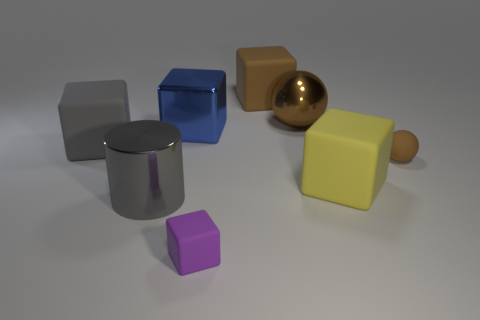Subtract all gray matte cubes. How many cubes are left? 4 Subtract all brown blocks. How many blocks are left? 4 Add 1 metal spheres. How many objects exist? 9 Subtract all blocks. How many objects are left? 3 Add 4 gray objects. How many gray objects are left? 6 Add 5 big blue metal cubes. How many big blue metal cubes exist? 6 Subtract 1 purple cubes. How many objects are left? 7 Subtract all cyan blocks. Subtract all green balls. How many blocks are left? 5 Subtract all big red objects. Subtract all large gray blocks. How many objects are left? 7 